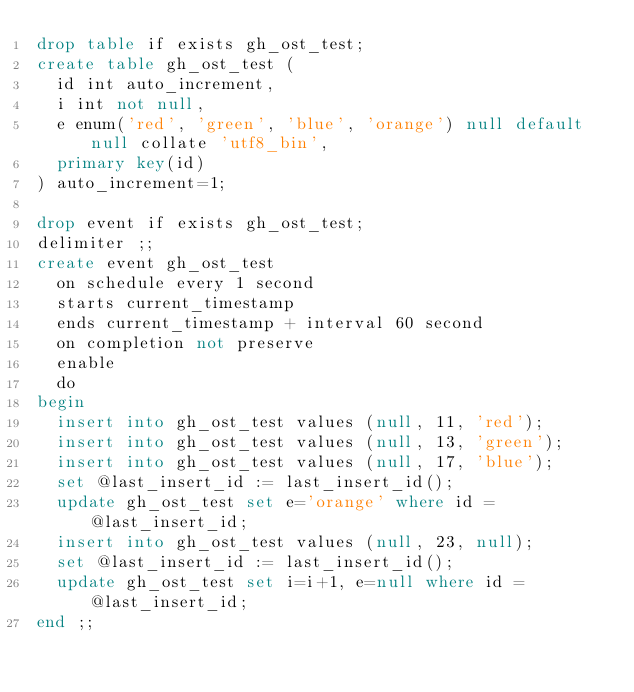Convert code to text. <code><loc_0><loc_0><loc_500><loc_500><_SQL_>drop table if exists gh_ost_test;
create table gh_ost_test (
  id int auto_increment,
  i int not null,
  e enum('red', 'green', 'blue', 'orange') null default null collate 'utf8_bin',
  primary key(id)
) auto_increment=1;

drop event if exists gh_ost_test;
delimiter ;;
create event gh_ost_test
  on schedule every 1 second
  starts current_timestamp
  ends current_timestamp + interval 60 second
  on completion not preserve
  enable
  do
begin
  insert into gh_ost_test values (null, 11, 'red');
  insert into gh_ost_test values (null, 13, 'green');
  insert into gh_ost_test values (null, 17, 'blue');
  set @last_insert_id := last_insert_id();
  update gh_ost_test set e='orange' where id = @last_insert_id;
  insert into gh_ost_test values (null, 23, null);
  set @last_insert_id := last_insert_id();
  update gh_ost_test set i=i+1, e=null where id = @last_insert_id;
end ;;
</code> 